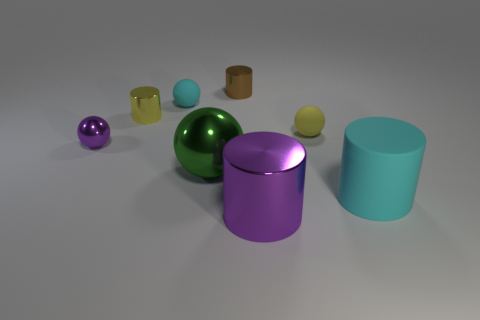What can you infer about the lighting in the scene? The lighting in the scene is soft and diffused, creating gentle shadows and subtle reflections on the objects. It appears to come from a source above and to the left, based on the shadow patterns on the ground. Does the lighting affect the colors of the objects? Yes, the lighting gives the objects a slightly muted tone and enhances their reflective properties, which can affect the perception of their colors by adding a sense of depth and richness. 